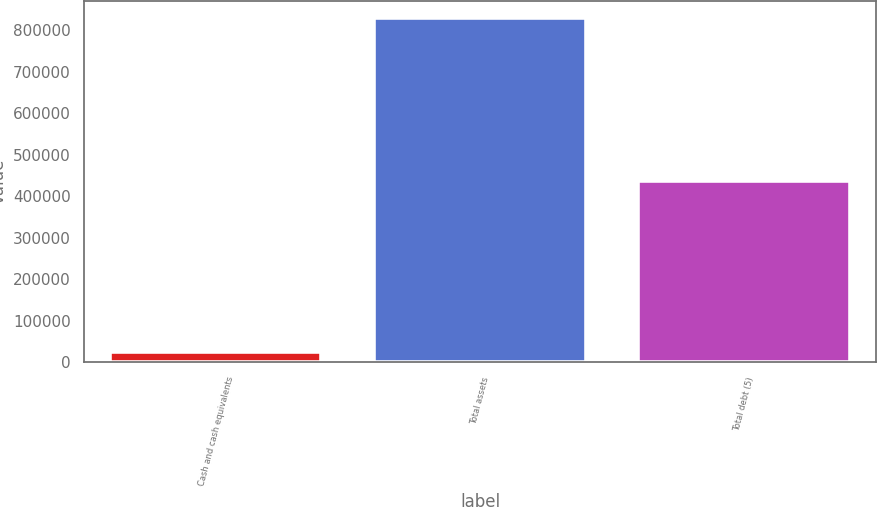Convert chart. <chart><loc_0><loc_0><loc_500><loc_500><bar_chart><fcel>Cash and cash equivalents<fcel>Total assets<fcel>Total debt (5)<nl><fcel>24049<fcel>830041<fcel>438330<nl></chart> 